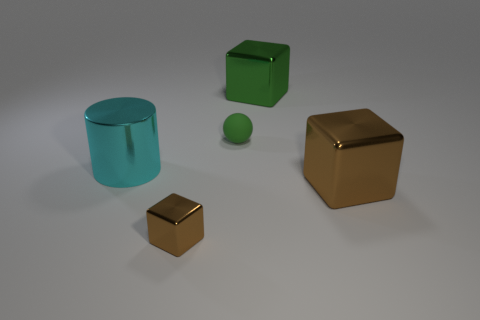Does the small shiny object have the same color as the small sphere? No, they do not share the same color. The small shiny object appears to be gold-toned, while the small sphere is green, complementing the larger green cube next to it. 